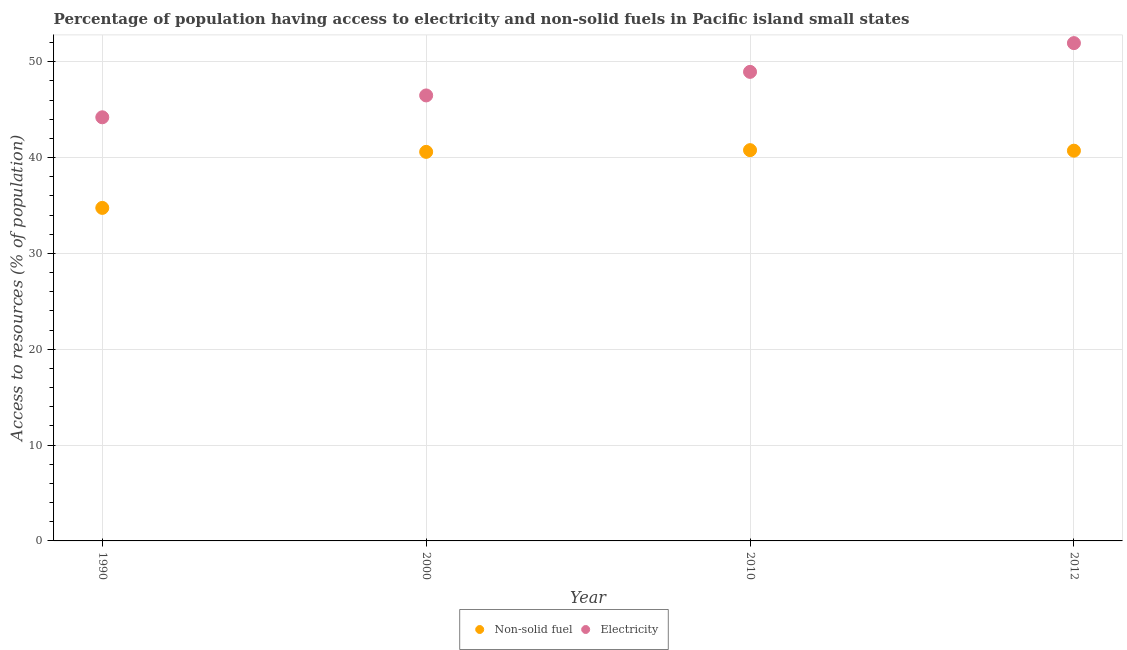How many different coloured dotlines are there?
Your response must be concise. 2. Is the number of dotlines equal to the number of legend labels?
Provide a succinct answer. Yes. What is the percentage of population having access to non-solid fuel in 2012?
Provide a succinct answer. 40.72. Across all years, what is the maximum percentage of population having access to non-solid fuel?
Provide a succinct answer. 40.78. Across all years, what is the minimum percentage of population having access to non-solid fuel?
Make the answer very short. 34.75. In which year was the percentage of population having access to electricity maximum?
Keep it short and to the point. 2012. What is the total percentage of population having access to non-solid fuel in the graph?
Keep it short and to the point. 156.84. What is the difference between the percentage of population having access to electricity in 1990 and that in 2010?
Your response must be concise. -4.74. What is the difference between the percentage of population having access to non-solid fuel in 2010 and the percentage of population having access to electricity in 1990?
Offer a very short reply. -3.43. What is the average percentage of population having access to electricity per year?
Keep it short and to the point. 47.89. In the year 2012, what is the difference between the percentage of population having access to non-solid fuel and percentage of population having access to electricity?
Keep it short and to the point. -11.22. What is the ratio of the percentage of population having access to electricity in 2000 to that in 2012?
Your answer should be compact. 0.89. What is the difference between the highest and the second highest percentage of population having access to electricity?
Give a very brief answer. 3. What is the difference between the highest and the lowest percentage of population having access to non-solid fuel?
Your response must be concise. 6.03. In how many years, is the percentage of population having access to non-solid fuel greater than the average percentage of population having access to non-solid fuel taken over all years?
Your response must be concise. 3. Is the sum of the percentage of population having access to non-solid fuel in 1990 and 2010 greater than the maximum percentage of population having access to electricity across all years?
Offer a very short reply. Yes. Is the percentage of population having access to non-solid fuel strictly greater than the percentage of population having access to electricity over the years?
Provide a short and direct response. No. Are the values on the major ticks of Y-axis written in scientific E-notation?
Provide a succinct answer. No. Does the graph contain any zero values?
Make the answer very short. No. Does the graph contain grids?
Your response must be concise. Yes. How are the legend labels stacked?
Make the answer very short. Horizontal. What is the title of the graph?
Your answer should be compact. Percentage of population having access to electricity and non-solid fuels in Pacific island small states. Does "Current education expenditure" appear as one of the legend labels in the graph?
Ensure brevity in your answer.  No. What is the label or title of the X-axis?
Provide a succinct answer. Year. What is the label or title of the Y-axis?
Give a very brief answer. Access to resources (% of population). What is the Access to resources (% of population) of Non-solid fuel in 1990?
Make the answer very short. 34.75. What is the Access to resources (% of population) in Electricity in 1990?
Keep it short and to the point. 44.2. What is the Access to resources (% of population) in Non-solid fuel in 2000?
Your answer should be very brief. 40.6. What is the Access to resources (% of population) of Electricity in 2000?
Offer a terse response. 46.48. What is the Access to resources (% of population) of Non-solid fuel in 2010?
Provide a succinct answer. 40.78. What is the Access to resources (% of population) in Electricity in 2010?
Your answer should be very brief. 48.94. What is the Access to resources (% of population) of Non-solid fuel in 2012?
Make the answer very short. 40.72. What is the Access to resources (% of population) in Electricity in 2012?
Your response must be concise. 51.94. Across all years, what is the maximum Access to resources (% of population) in Non-solid fuel?
Your answer should be compact. 40.78. Across all years, what is the maximum Access to resources (% of population) in Electricity?
Your response must be concise. 51.94. Across all years, what is the minimum Access to resources (% of population) of Non-solid fuel?
Make the answer very short. 34.75. Across all years, what is the minimum Access to resources (% of population) in Electricity?
Provide a short and direct response. 44.2. What is the total Access to resources (% of population) of Non-solid fuel in the graph?
Provide a succinct answer. 156.84. What is the total Access to resources (% of population) in Electricity in the graph?
Provide a succinct answer. 191.58. What is the difference between the Access to resources (% of population) in Non-solid fuel in 1990 and that in 2000?
Your response must be concise. -5.85. What is the difference between the Access to resources (% of population) of Electricity in 1990 and that in 2000?
Ensure brevity in your answer.  -2.28. What is the difference between the Access to resources (% of population) of Non-solid fuel in 1990 and that in 2010?
Your answer should be compact. -6.03. What is the difference between the Access to resources (% of population) of Electricity in 1990 and that in 2010?
Keep it short and to the point. -4.74. What is the difference between the Access to resources (% of population) of Non-solid fuel in 1990 and that in 2012?
Offer a terse response. -5.97. What is the difference between the Access to resources (% of population) of Electricity in 1990 and that in 2012?
Offer a terse response. -7.74. What is the difference between the Access to resources (% of population) in Non-solid fuel in 2000 and that in 2010?
Make the answer very short. -0.18. What is the difference between the Access to resources (% of population) of Electricity in 2000 and that in 2010?
Ensure brevity in your answer.  -2.46. What is the difference between the Access to resources (% of population) in Non-solid fuel in 2000 and that in 2012?
Provide a short and direct response. -0.12. What is the difference between the Access to resources (% of population) of Electricity in 2000 and that in 2012?
Provide a succinct answer. -5.46. What is the difference between the Access to resources (% of population) in Non-solid fuel in 2010 and that in 2012?
Ensure brevity in your answer.  0.06. What is the difference between the Access to resources (% of population) of Electricity in 2010 and that in 2012?
Offer a terse response. -3. What is the difference between the Access to resources (% of population) of Non-solid fuel in 1990 and the Access to resources (% of population) of Electricity in 2000?
Provide a succinct answer. -11.73. What is the difference between the Access to resources (% of population) of Non-solid fuel in 1990 and the Access to resources (% of population) of Electricity in 2010?
Your answer should be compact. -14.19. What is the difference between the Access to resources (% of population) of Non-solid fuel in 1990 and the Access to resources (% of population) of Electricity in 2012?
Provide a succinct answer. -17.19. What is the difference between the Access to resources (% of population) in Non-solid fuel in 2000 and the Access to resources (% of population) in Electricity in 2010?
Offer a very short reply. -8.35. What is the difference between the Access to resources (% of population) of Non-solid fuel in 2000 and the Access to resources (% of population) of Electricity in 2012?
Keep it short and to the point. -11.35. What is the difference between the Access to resources (% of population) of Non-solid fuel in 2010 and the Access to resources (% of population) of Electricity in 2012?
Offer a terse response. -11.17. What is the average Access to resources (% of population) in Non-solid fuel per year?
Offer a terse response. 39.21. What is the average Access to resources (% of population) in Electricity per year?
Give a very brief answer. 47.89. In the year 1990, what is the difference between the Access to resources (% of population) in Non-solid fuel and Access to resources (% of population) in Electricity?
Your response must be concise. -9.45. In the year 2000, what is the difference between the Access to resources (% of population) in Non-solid fuel and Access to resources (% of population) in Electricity?
Your answer should be very brief. -5.89. In the year 2010, what is the difference between the Access to resources (% of population) in Non-solid fuel and Access to resources (% of population) in Electricity?
Offer a terse response. -8.17. In the year 2012, what is the difference between the Access to resources (% of population) of Non-solid fuel and Access to resources (% of population) of Electricity?
Your answer should be very brief. -11.22. What is the ratio of the Access to resources (% of population) in Non-solid fuel in 1990 to that in 2000?
Make the answer very short. 0.86. What is the ratio of the Access to resources (% of population) of Electricity in 1990 to that in 2000?
Your answer should be compact. 0.95. What is the ratio of the Access to resources (% of population) in Non-solid fuel in 1990 to that in 2010?
Offer a very short reply. 0.85. What is the ratio of the Access to resources (% of population) in Electricity in 1990 to that in 2010?
Your answer should be compact. 0.9. What is the ratio of the Access to resources (% of population) in Non-solid fuel in 1990 to that in 2012?
Provide a short and direct response. 0.85. What is the ratio of the Access to resources (% of population) of Electricity in 1990 to that in 2012?
Make the answer very short. 0.85. What is the ratio of the Access to resources (% of population) in Electricity in 2000 to that in 2010?
Your answer should be very brief. 0.95. What is the ratio of the Access to resources (% of population) of Electricity in 2000 to that in 2012?
Make the answer very short. 0.89. What is the ratio of the Access to resources (% of population) of Non-solid fuel in 2010 to that in 2012?
Give a very brief answer. 1. What is the ratio of the Access to resources (% of population) of Electricity in 2010 to that in 2012?
Give a very brief answer. 0.94. What is the difference between the highest and the second highest Access to resources (% of population) of Non-solid fuel?
Give a very brief answer. 0.06. What is the difference between the highest and the second highest Access to resources (% of population) of Electricity?
Keep it short and to the point. 3. What is the difference between the highest and the lowest Access to resources (% of population) in Non-solid fuel?
Make the answer very short. 6.03. What is the difference between the highest and the lowest Access to resources (% of population) of Electricity?
Give a very brief answer. 7.74. 